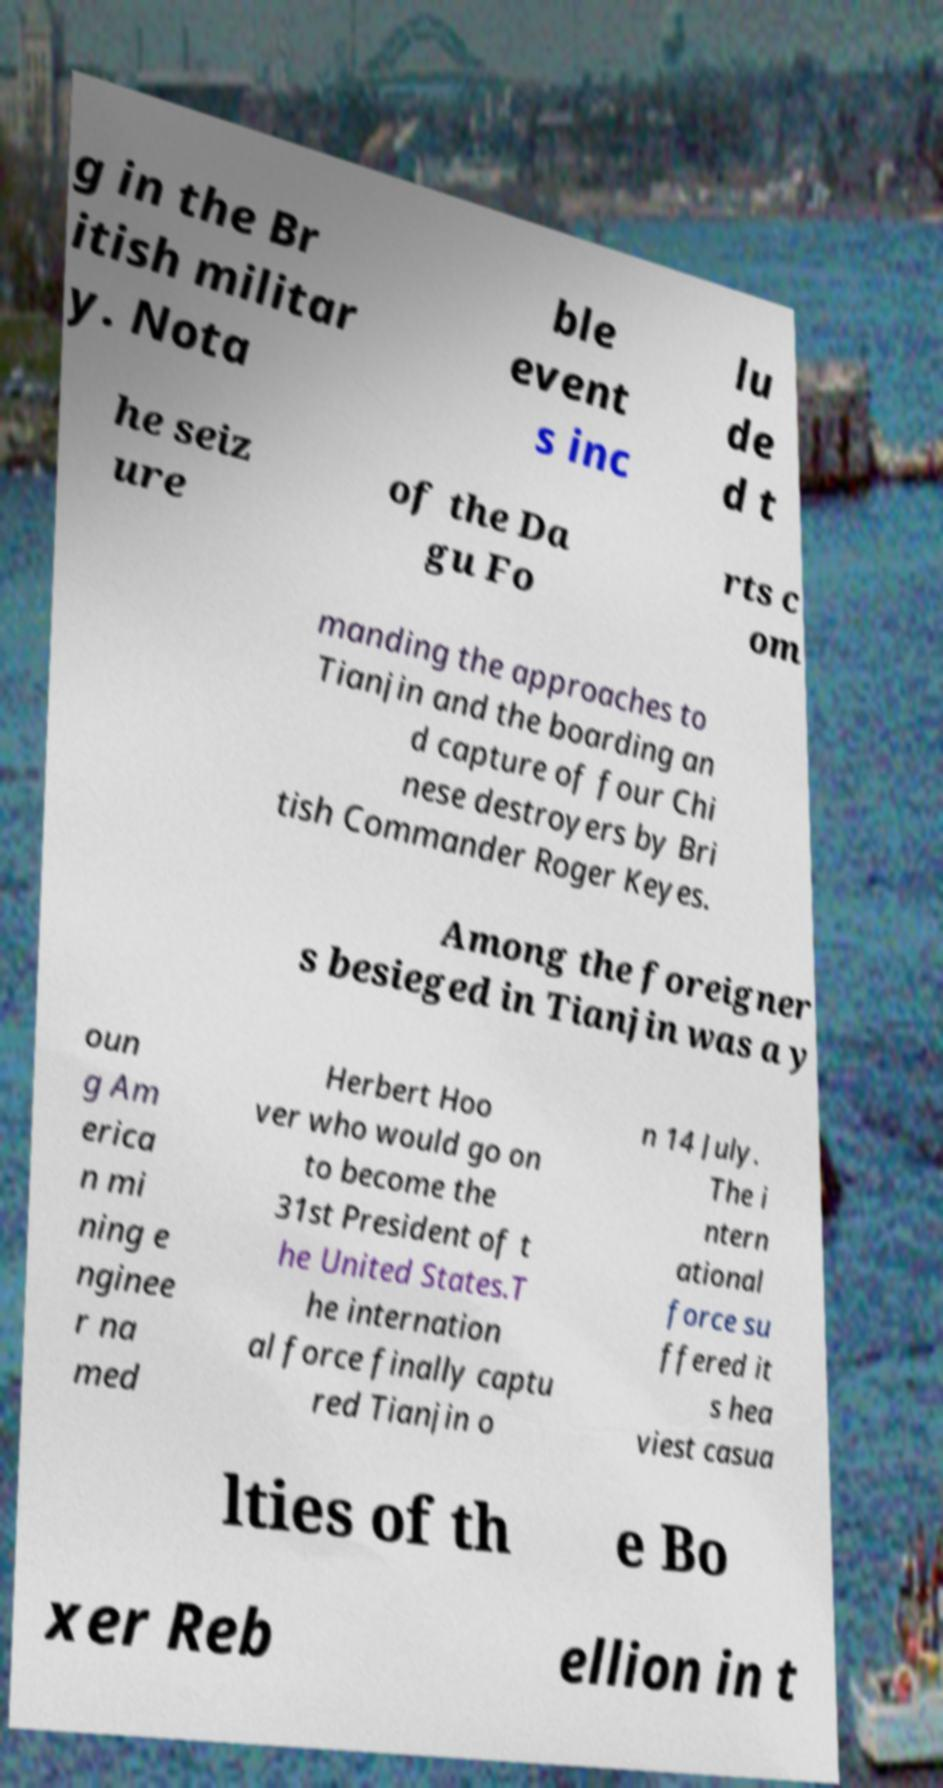Could you assist in decoding the text presented in this image and type it out clearly? g in the Br itish militar y. Nota ble event s inc lu de d t he seiz ure of the Da gu Fo rts c om manding the approaches to Tianjin and the boarding an d capture of four Chi nese destroyers by Bri tish Commander Roger Keyes. Among the foreigner s besieged in Tianjin was a y oun g Am erica n mi ning e nginee r na med Herbert Hoo ver who would go on to become the 31st President of t he United States.T he internation al force finally captu red Tianjin o n 14 July. The i ntern ational force su ffered it s hea viest casua lties of th e Bo xer Reb ellion in t 